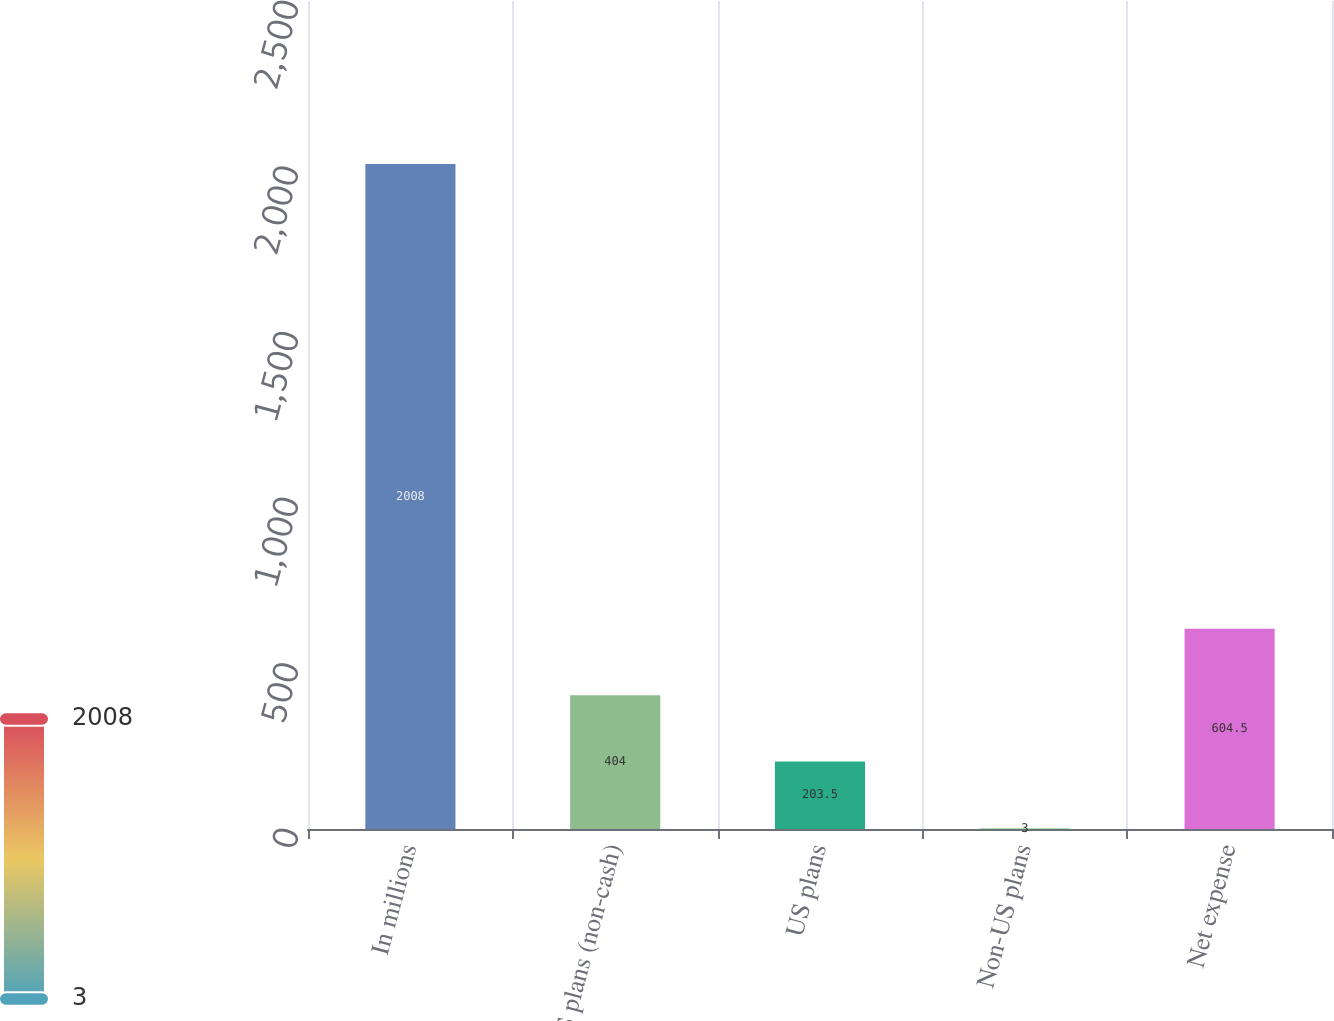<chart> <loc_0><loc_0><loc_500><loc_500><bar_chart><fcel>In millions<fcel>US plans (non-cash)<fcel>US plans<fcel>Non-US plans<fcel>Net expense<nl><fcel>2008<fcel>404<fcel>203.5<fcel>3<fcel>604.5<nl></chart> 